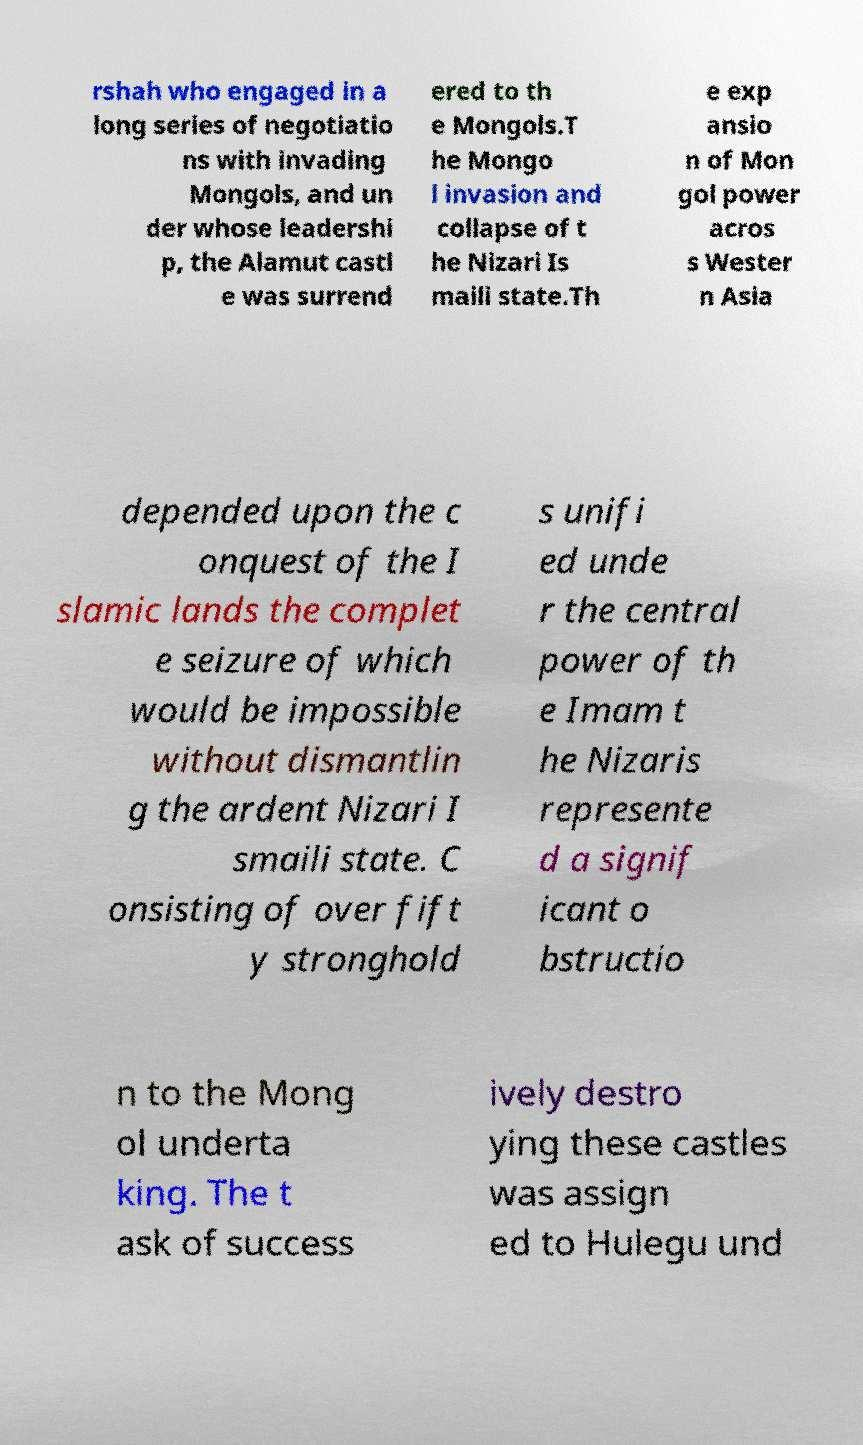Can you accurately transcribe the text from the provided image for me? rshah who engaged in a long series of negotiatio ns with invading Mongols, and un der whose leadershi p, the Alamut castl e was surrend ered to th e Mongols.T he Mongo l invasion and collapse of t he Nizari Is maili state.Th e exp ansio n of Mon gol power acros s Wester n Asia depended upon the c onquest of the I slamic lands the complet e seizure of which would be impossible without dismantlin g the ardent Nizari I smaili state. C onsisting of over fift y stronghold s unifi ed unde r the central power of th e Imam t he Nizaris represente d a signif icant o bstructio n to the Mong ol underta king. The t ask of success ively destro ying these castles was assign ed to Hulegu und 